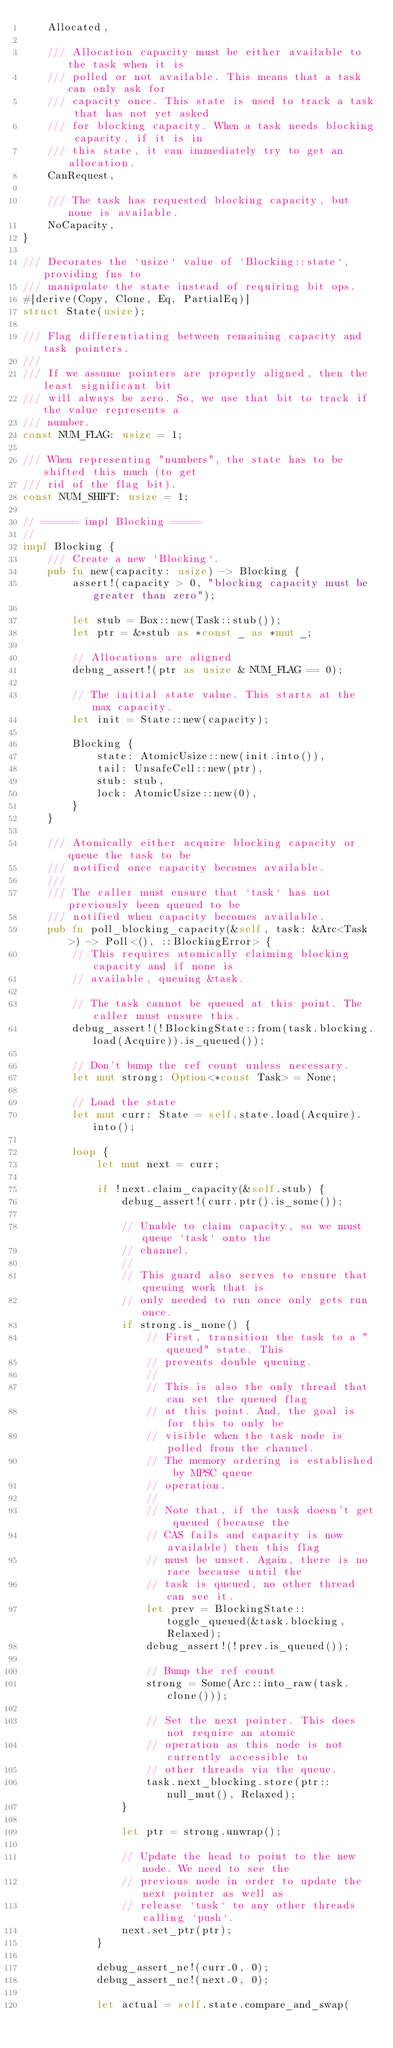Convert code to text. <code><loc_0><loc_0><loc_500><loc_500><_Rust_>    Allocated,

    /// Allocation capacity must be either available to the task when it is
    /// polled or not available. This means that a task can only ask for
    /// capacity once. This state is used to track a task that has not yet asked
    /// for blocking capacity. When a task needs blocking capacity, if it is in
    /// this state, it can immediately try to get an allocation.
    CanRequest,

    /// The task has requested blocking capacity, but none is available.
    NoCapacity,
}

/// Decorates the `usize` value of `Blocking::state`, providing fns to
/// manipulate the state instead of requiring bit ops.
#[derive(Copy, Clone, Eq, PartialEq)]
struct State(usize);

/// Flag differentiating between remaining capacity and task pointers.
///
/// If we assume pointers are properly aligned, then the least significant bit
/// will always be zero. So, we use that bit to track if the value represents a
/// number.
const NUM_FLAG: usize = 1;

/// When representing "numbers", the state has to be shifted this much (to get
/// rid of the flag bit).
const NUM_SHIFT: usize = 1;

// ====== impl Blocking =====
//
impl Blocking {
    /// Create a new `Blocking`.
    pub fn new(capacity: usize) -> Blocking {
        assert!(capacity > 0, "blocking capacity must be greater than zero");

        let stub = Box::new(Task::stub());
        let ptr = &*stub as *const _ as *mut _;

        // Allocations are aligned
        debug_assert!(ptr as usize & NUM_FLAG == 0);

        // The initial state value. This starts at the max capacity.
        let init = State::new(capacity);

        Blocking {
            state: AtomicUsize::new(init.into()),
            tail: UnsafeCell::new(ptr),
            stub: stub,
            lock: AtomicUsize::new(0),
        }
    }

    /// Atomically either acquire blocking capacity or queue the task to be
    /// notified once capacity becomes available.
    ///
    /// The caller must ensure that `task` has not previously been queued to be
    /// notified when capacity becomes available.
    pub fn poll_blocking_capacity(&self, task: &Arc<Task>) -> Poll<(), ::BlockingError> {
        // This requires atomically claiming blocking capacity and if none is
        // available, queuing &task.

        // The task cannot be queued at this point. The caller must ensure this.
        debug_assert!(!BlockingState::from(task.blocking.load(Acquire)).is_queued());

        // Don't bump the ref count unless necessary.
        let mut strong: Option<*const Task> = None;

        // Load the state
        let mut curr: State = self.state.load(Acquire).into();

        loop {
            let mut next = curr;

            if !next.claim_capacity(&self.stub) {
                debug_assert!(curr.ptr().is_some());

                // Unable to claim capacity, so we must queue `task` onto the
                // channel.
                //
                // This guard also serves to ensure that queuing work that is
                // only needed to run once only gets run once.
                if strong.is_none() {
                    // First, transition the task to a "queued" state. This
                    // prevents double queuing.
                    //
                    // This is also the only thread that can set the queued flag
                    // at this point. And, the goal is for this to only be
                    // visible when the task node is polled from the channel.
                    // The memory ordering is established by MPSC queue
                    // operation.
                    //
                    // Note that, if the task doesn't get queued (because the
                    // CAS fails and capacity is now available) then this flag
                    // must be unset. Again, there is no race because until the
                    // task is queued, no other thread can see it.
                    let prev = BlockingState::toggle_queued(&task.blocking, Relaxed);
                    debug_assert!(!prev.is_queued());

                    // Bump the ref count
                    strong = Some(Arc::into_raw(task.clone()));

                    // Set the next pointer. This does not require an atomic
                    // operation as this node is not currently accessible to
                    // other threads via the queue.
                    task.next_blocking.store(ptr::null_mut(), Relaxed);
                }

                let ptr = strong.unwrap();

                // Update the head to point to the new node. We need to see the
                // previous node in order to update the next pointer as well as
                // release `task` to any other threads calling `push`.
                next.set_ptr(ptr);
            }

            debug_assert_ne!(curr.0, 0);
            debug_assert_ne!(next.0, 0);

            let actual = self.state.compare_and_swap(</code> 